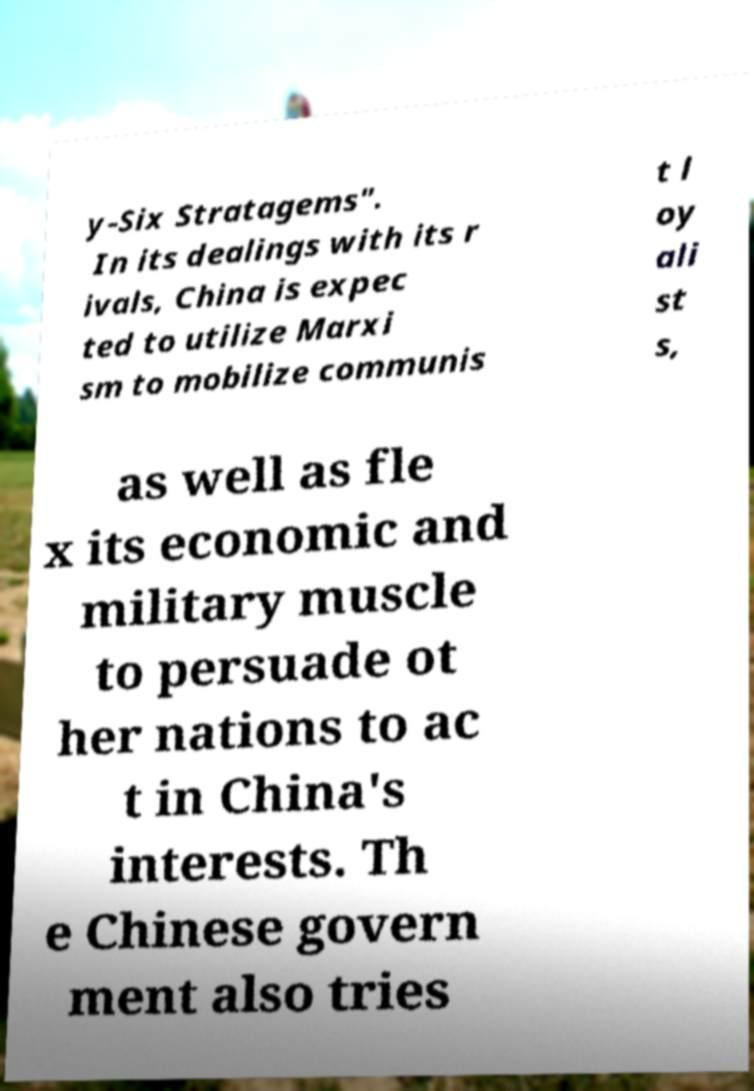What messages or text are displayed in this image? I need them in a readable, typed format. y-Six Stratagems". In its dealings with its r ivals, China is expec ted to utilize Marxi sm to mobilize communis t l oy ali st s, as well as fle x its economic and military muscle to persuade ot her nations to ac t in China's interests. Th e Chinese govern ment also tries 